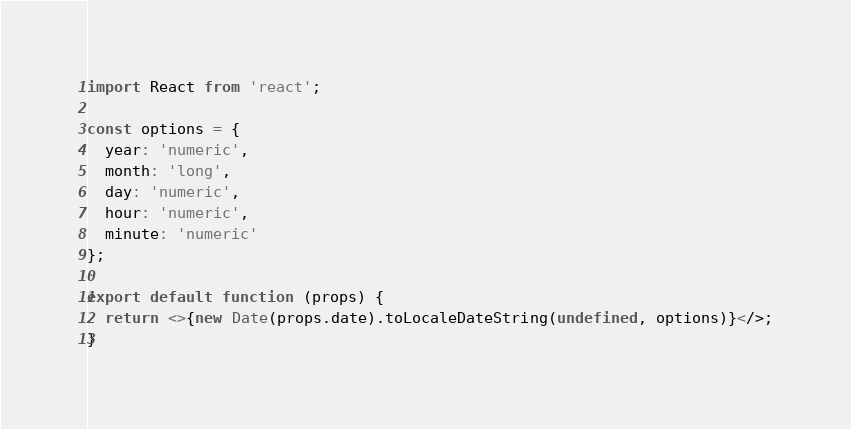<code> <loc_0><loc_0><loc_500><loc_500><_JavaScript_>import React from 'react';

const options = {
  year: 'numeric',
  month: 'long',
  day: 'numeric',
  hour: 'numeric',
  minute: 'numeric'
};

export default function (props) {
  return <>{new Date(props.date).toLocaleDateString(undefined, options)}</>;
}
</code> 